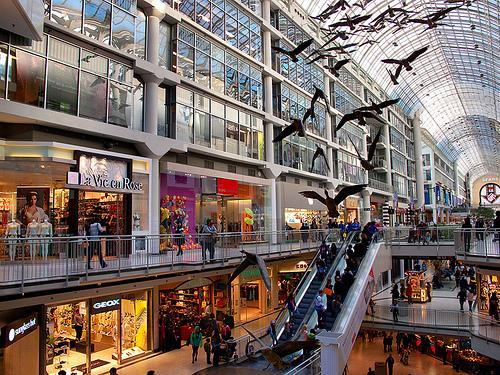What is this type of building called? Please explain your reasoning. mall. There are many stores. 